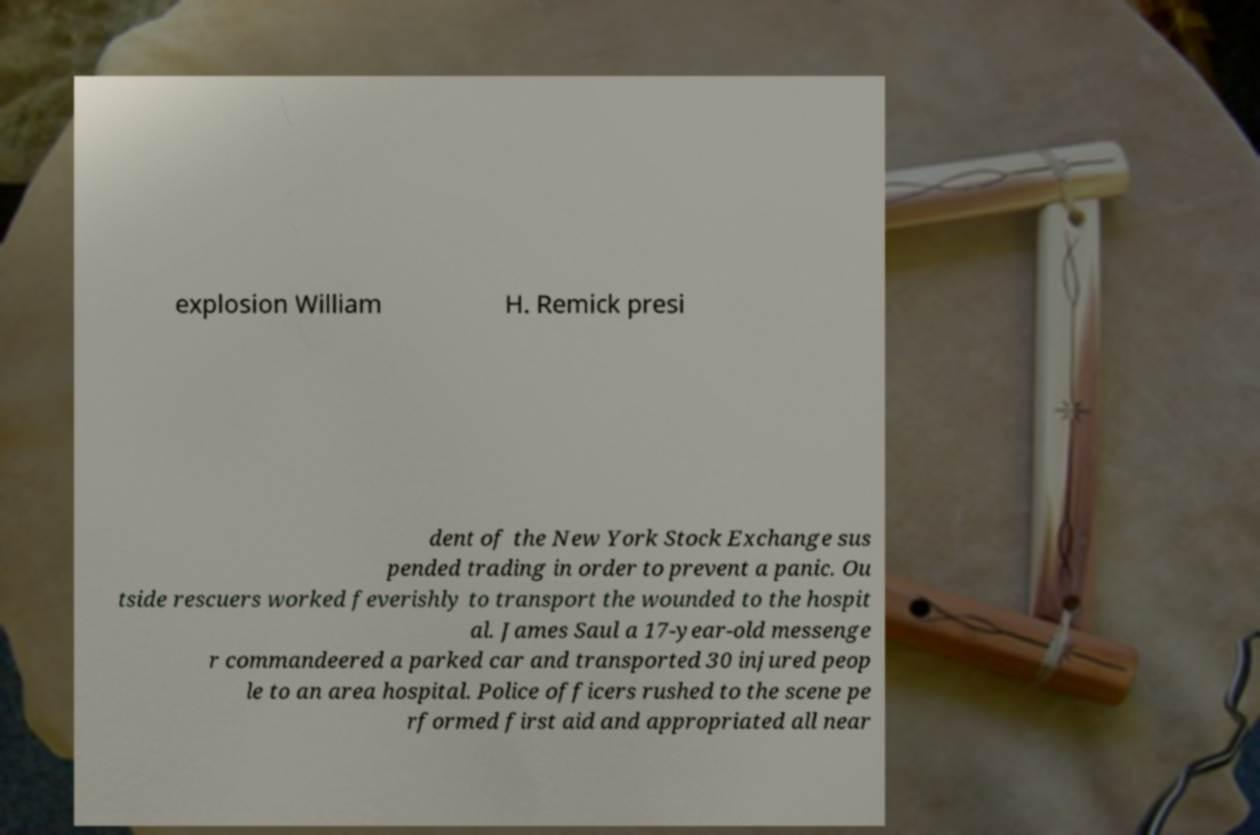Please read and relay the text visible in this image. What does it say? explosion William H. Remick presi dent of the New York Stock Exchange sus pended trading in order to prevent a panic. Ou tside rescuers worked feverishly to transport the wounded to the hospit al. James Saul a 17-year-old messenge r commandeered a parked car and transported 30 injured peop le to an area hospital. Police officers rushed to the scene pe rformed first aid and appropriated all near 